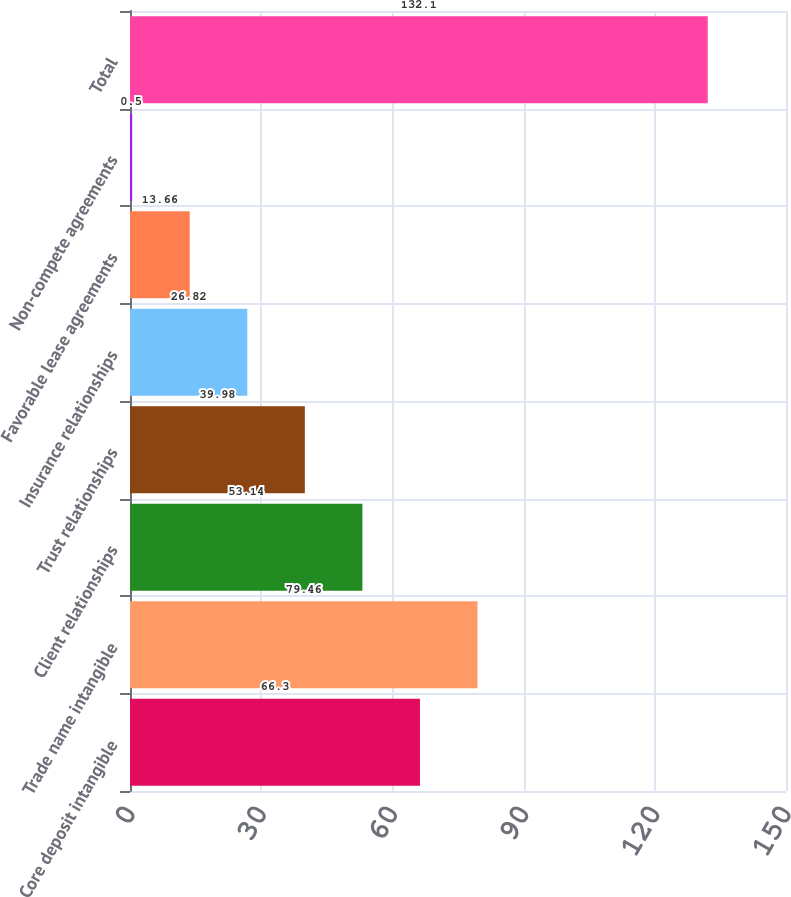Convert chart. <chart><loc_0><loc_0><loc_500><loc_500><bar_chart><fcel>Core deposit intangible<fcel>Trade name intangible<fcel>Client relationships<fcel>Trust relationships<fcel>Insurance relationships<fcel>Favorable lease agreements<fcel>Non-compete agreements<fcel>Total<nl><fcel>66.3<fcel>79.46<fcel>53.14<fcel>39.98<fcel>26.82<fcel>13.66<fcel>0.5<fcel>132.1<nl></chart> 